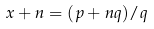Convert formula to latex. <formula><loc_0><loc_0><loc_500><loc_500>x + n = ( p + n q ) / q</formula> 